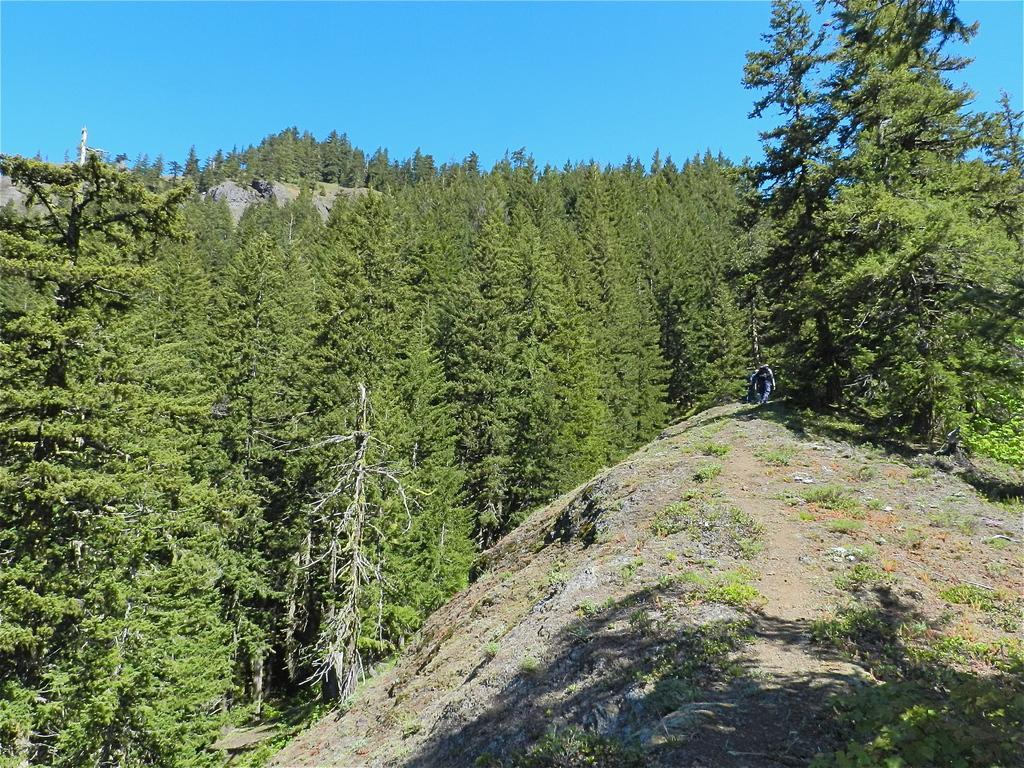In one or two sentences, can you explain what this image depicts? These are the green color trees. At the top it is the blue color sky. 